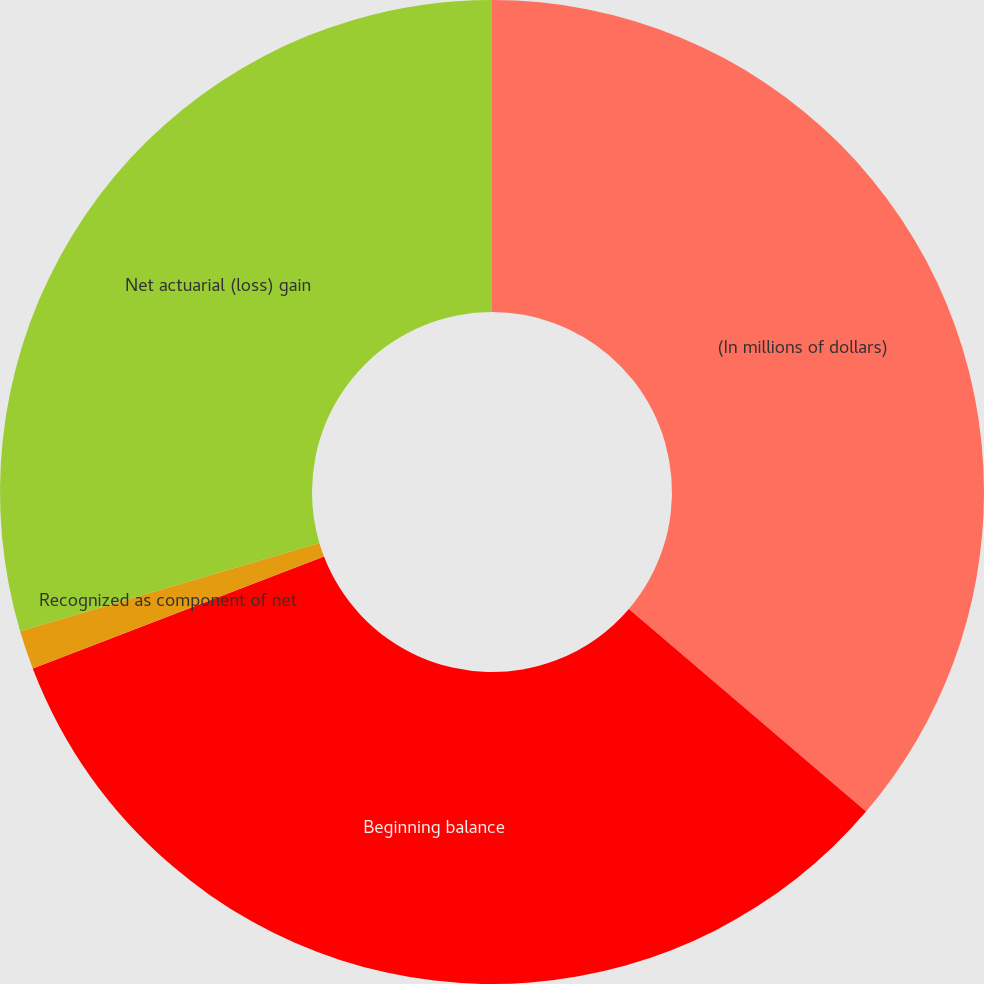Convert chart. <chart><loc_0><loc_0><loc_500><loc_500><pie_chart><fcel>(In millions of dollars)<fcel>Beginning balance<fcel>Recognized as component of net<fcel>Net actuarial (loss) gain<nl><fcel>36.25%<fcel>32.91%<fcel>1.27%<fcel>29.57%<nl></chart> 